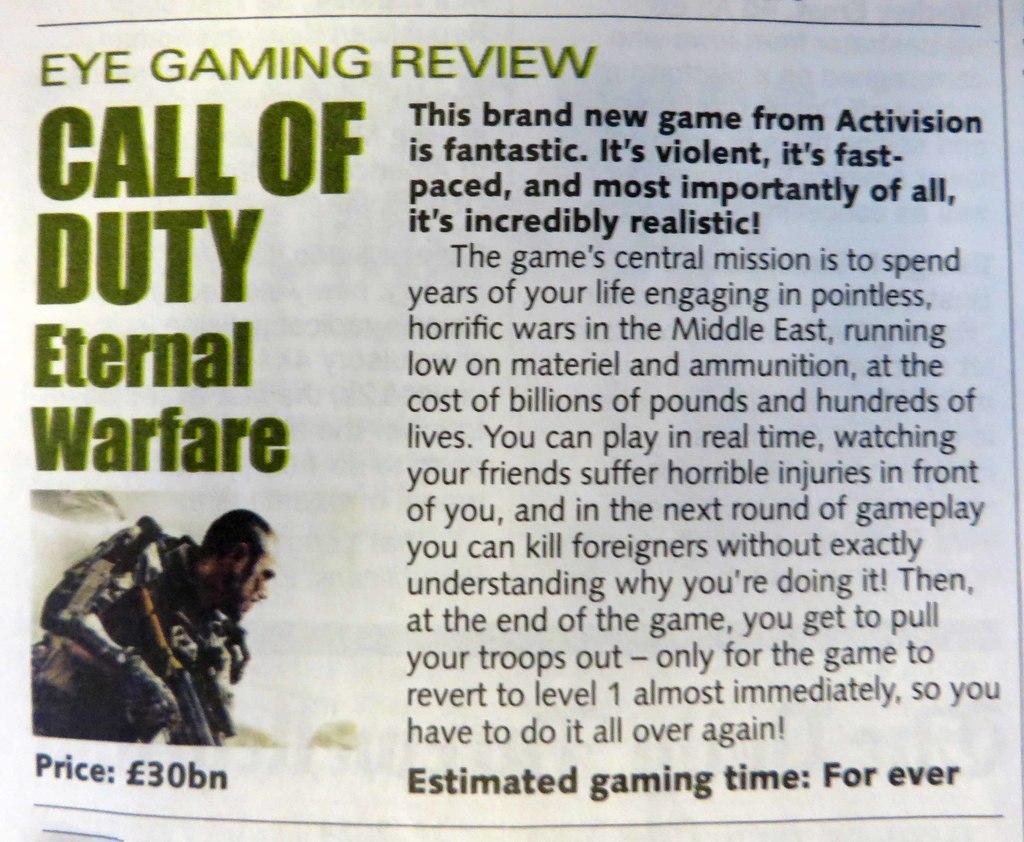<image>
Offer a succinct explanation of the picture presented. a magazine that has Call of Duty written in it 